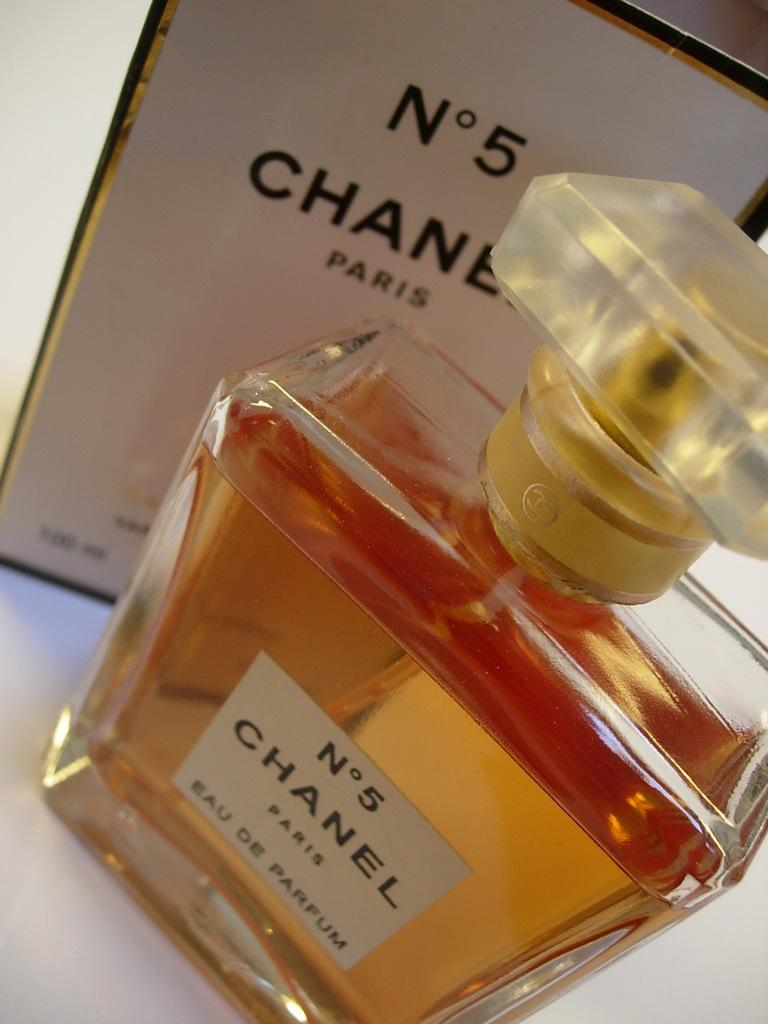<image>
Describe the image concisely. Channel No. 5 perfume container in front of its box 